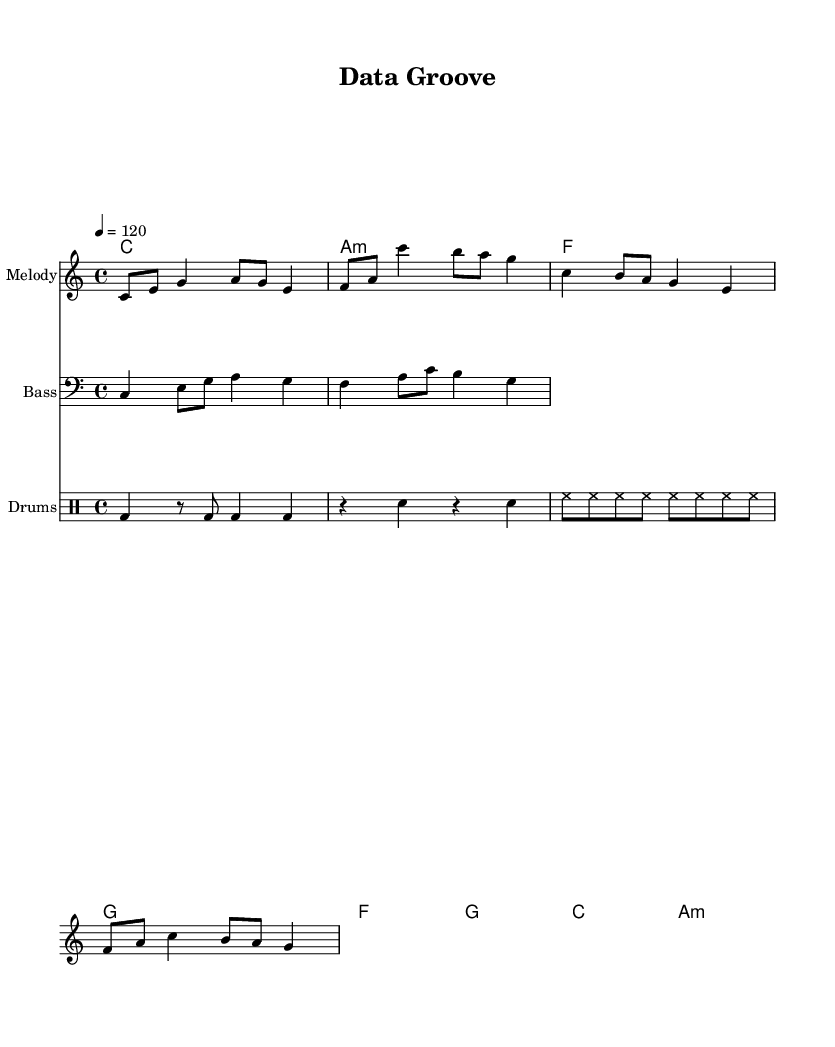What is the key signature of this music? The key signature is C major, which has no sharps or flats indicated in the global settings.
Answer: C major What is the time signature used in this piece? The time signature is 4/4, which is indicated at the beginning of the global section of the sheet music.
Answer: 4/4 What is the tempo of the song? The tempo is marked as 120 beats per minute, as noted in the global section of the sheet music.
Answer: 120 What are the lyrics for the chorus section? The chorus lyrics are present in the lyrics section and start with "Pattern recognition, it's our mission...".
Answer: Pattern recognition, it's our mission Which chord precedes the "g" chord in the verse section? The chord progression shows that the "f" chord directly precedes the "g" chord in the verse chords.
Answer: f How many distinct sections are there in the song? The song contains two main sections: a verse and a chorus, which can be observed in the arrangement of lyrics and chords.
Answer: Two What rhythmic element is primarily used in the drum part? The drum part primarily features a consistent kick drum (bd) pattern, with additional snare (sn) and hi-hat (hh) rhythms layered throughout.
Answer: Kick drum 